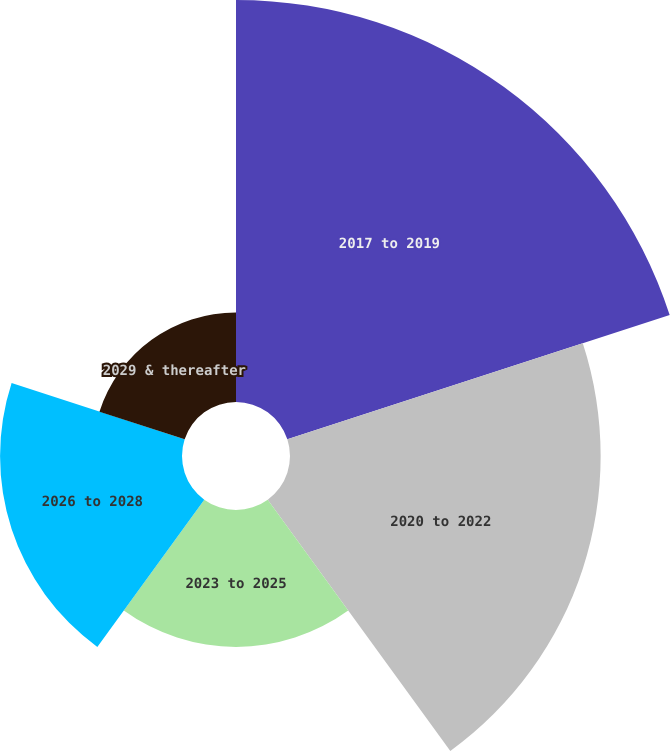<chart> <loc_0><loc_0><loc_500><loc_500><pie_chart><fcel>2017 to 2019<fcel>2020 to 2022<fcel>2023 to 2025<fcel>2026 to 2028<fcel>2029 & thereafter<nl><fcel>35.86%<fcel>27.71%<fcel>12.21%<fcel>16.23%<fcel>7.99%<nl></chart> 